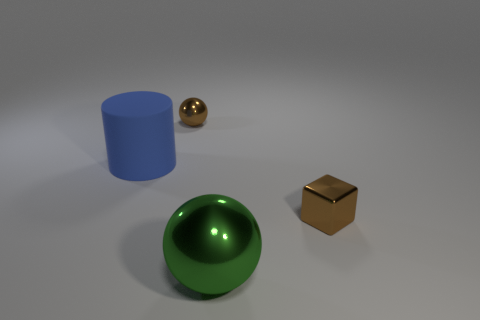There is a small object that is the same color as the tiny sphere; what is it made of?
Your response must be concise. Metal. There is a brown metallic thing in front of the blue rubber cylinder; what is its shape?
Give a very brief answer. Cube. How many small things are there?
Provide a short and direct response. 2. What color is the big sphere that is made of the same material as the tiny brown sphere?
Give a very brief answer. Green. What number of small objects are either green shiny things or cyan metal cubes?
Provide a short and direct response. 0. What number of small brown metallic objects are on the left side of the cube?
Provide a succinct answer. 1. There is a tiny object that is the same shape as the large green object; what color is it?
Give a very brief answer. Brown. How many shiny things are either small blue blocks or blue objects?
Offer a very short reply. 0. There is a tiny brown object in front of the brown thing that is left of the big green thing; are there any green objects that are behind it?
Provide a succinct answer. No. What is the color of the large metal thing?
Give a very brief answer. Green. 